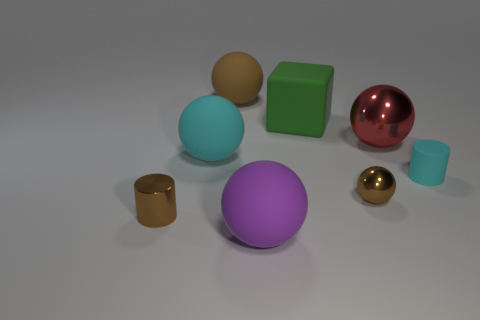There is a big object that is the same color as the rubber cylinder; what is it made of?
Keep it short and to the point. Rubber. What is the shape of the matte object that is to the right of the big sphere that is on the right side of the rubber thing that is in front of the small ball?
Your answer should be compact. Cylinder. There is a ball that is on the left side of the big purple sphere and in front of the large red thing; what is its material?
Give a very brief answer. Rubber. How many rubber cylinders have the same size as the shiny cylinder?
Make the answer very short. 1. How many metallic things are either tiny cyan cubes or large things?
Ensure brevity in your answer.  1. What is the big green thing made of?
Your response must be concise. Rubber. What number of small brown metallic spheres are in front of the small brown cylinder?
Offer a very short reply. 0. Is the brown thing that is right of the big green rubber cube made of the same material as the cyan cylinder?
Provide a succinct answer. No. How many large green things have the same shape as the large cyan thing?
Your response must be concise. 0. How many tiny things are brown matte things or brown shiny cylinders?
Keep it short and to the point. 1. 